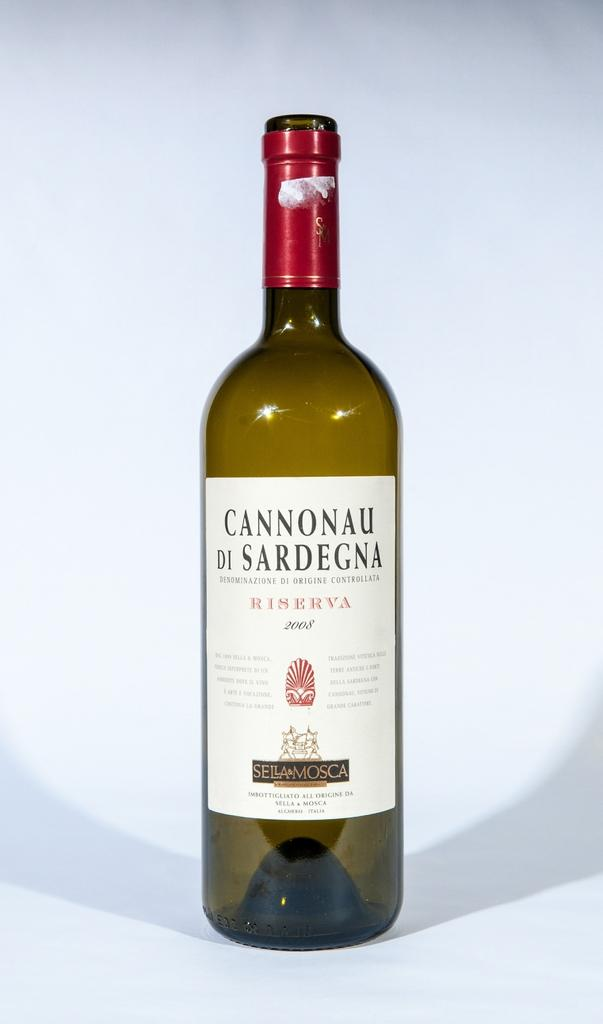<image>
Write a terse but informative summary of the picture. An open bottle of Cannonau Di Sardegna sits in from of a white background. 